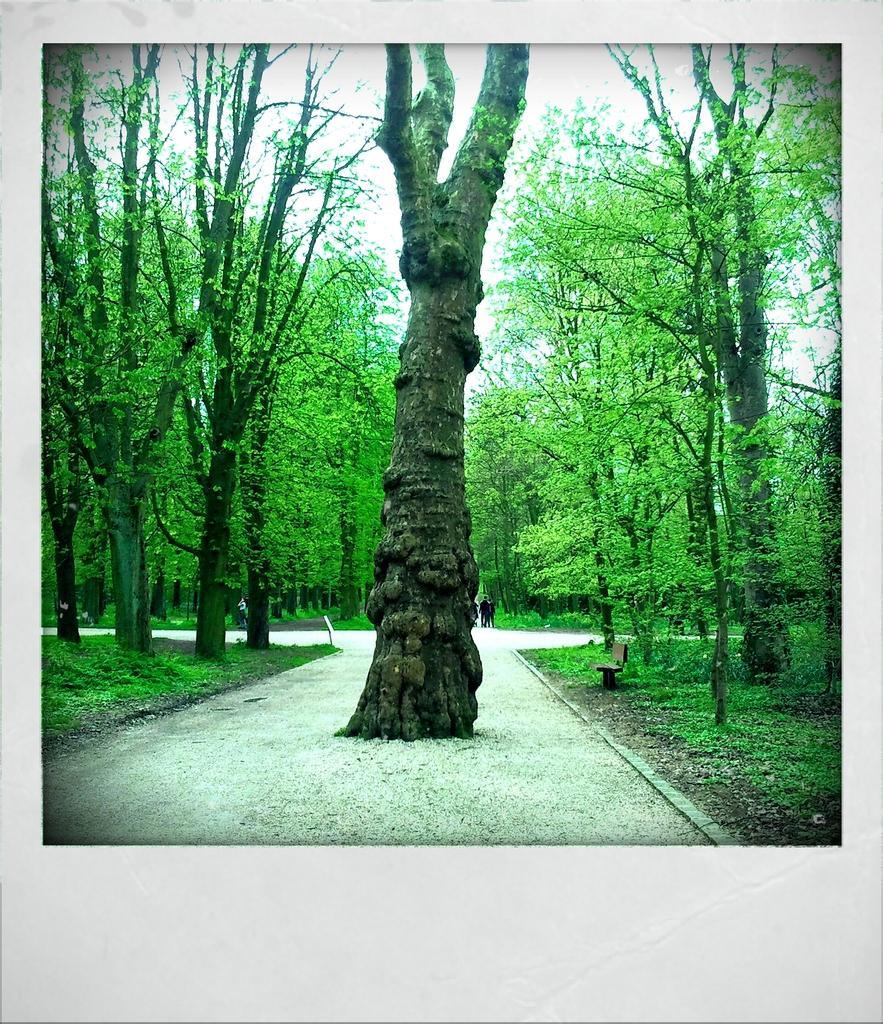What type of vegetation can be seen in the image? There are trees in the image. What type of man-made structure is visible in the image? There is a road in the image. What is visible in the background of the image? The sky is visible in the background of the image. What type of silk can be seen hanging from the trees in the image? There is no silk present in the image; it features trees and a road. Can you tell me how many yaks are grazing on the side of the road in the image? There are no yaks present in the image; it only shows trees, a road, and the sky. 